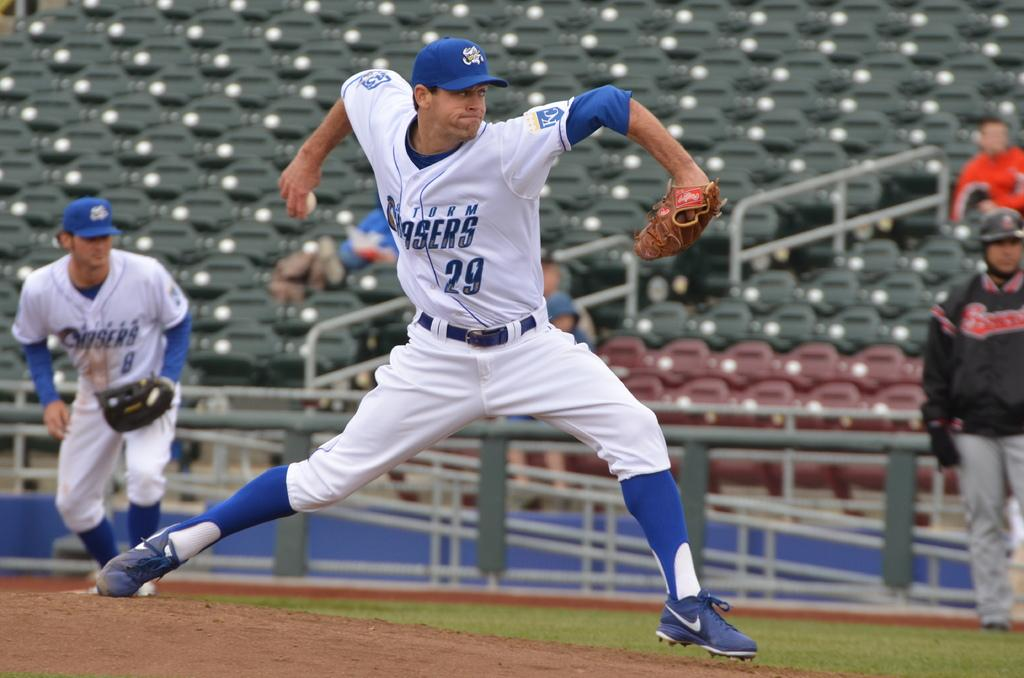<image>
Provide a brief description of the given image. Player number 29 is winding up to pitch a baseball. 